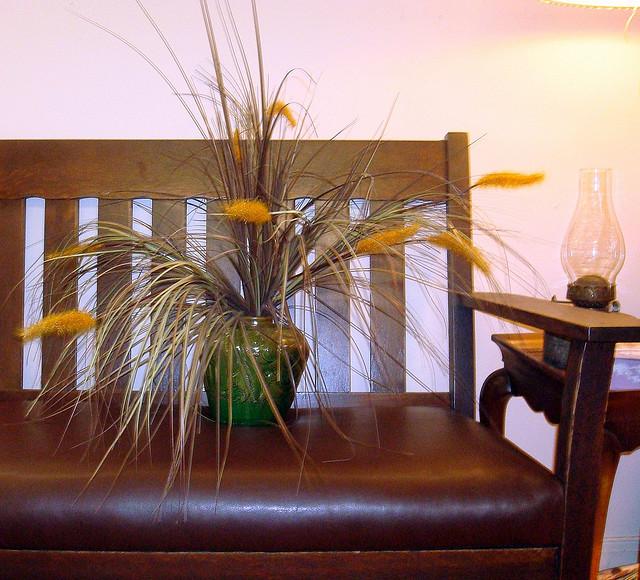Who is sitting on the bench?
Give a very brief answer. No one. Is the back of the bench cushioned?
Write a very short answer. No. What does the object on the table do?
Quick response, please. Light. 